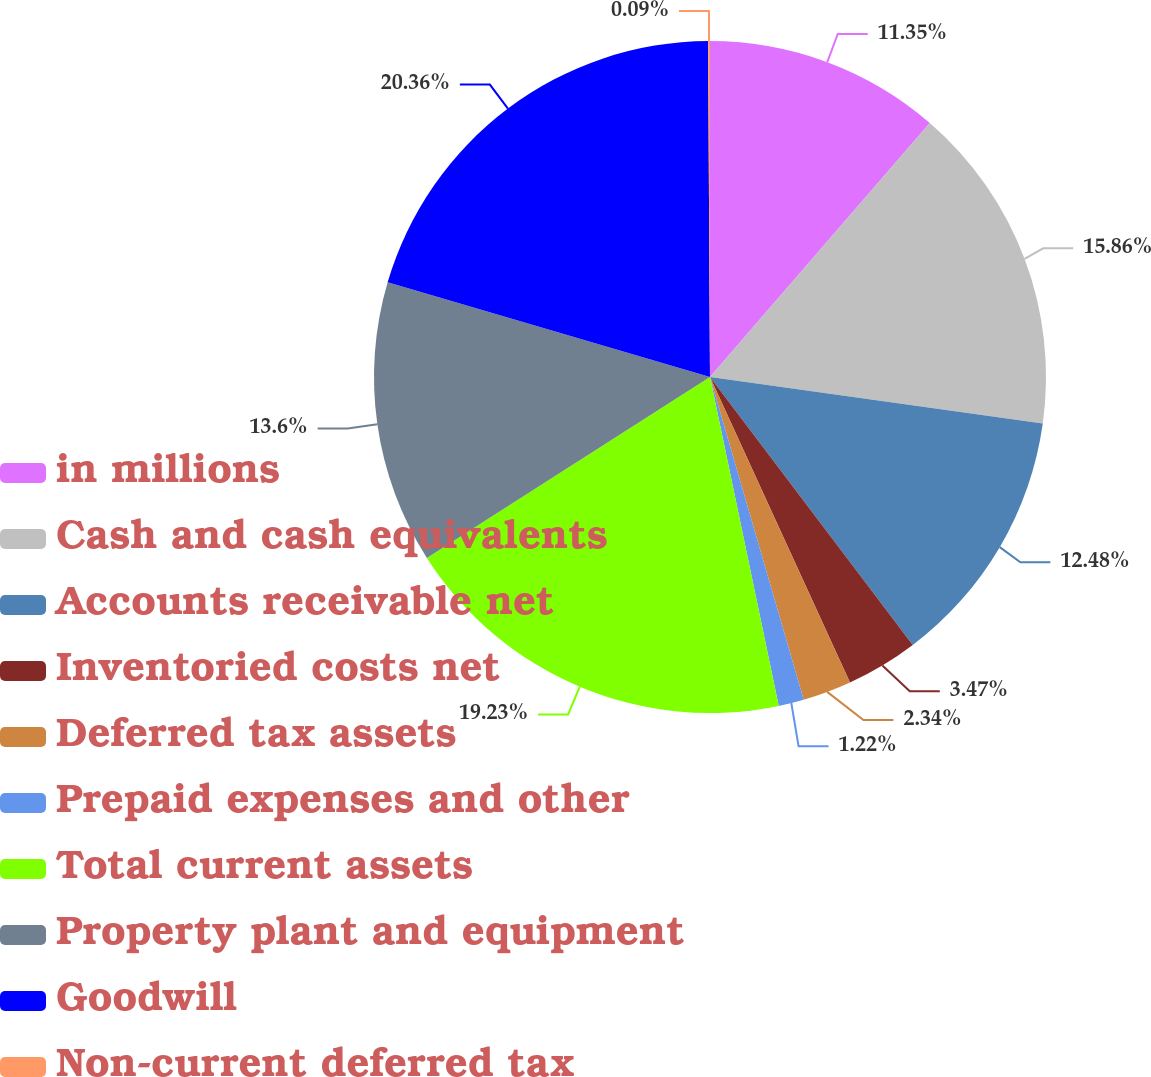<chart> <loc_0><loc_0><loc_500><loc_500><pie_chart><fcel>in millions<fcel>Cash and cash equivalents<fcel>Accounts receivable net<fcel>Inventoried costs net<fcel>Deferred tax assets<fcel>Prepaid expenses and other<fcel>Total current assets<fcel>Property plant and equipment<fcel>Goodwill<fcel>Non-current deferred tax<nl><fcel>11.35%<fcel>15.86%<fcel>12.48%<fcel>3.47%<fcel>2.34%<fcel>1.22%<fcel>19.23%<fcel>13.6%<fcel>20.36%<fcel>0.09%<nl></chart> 